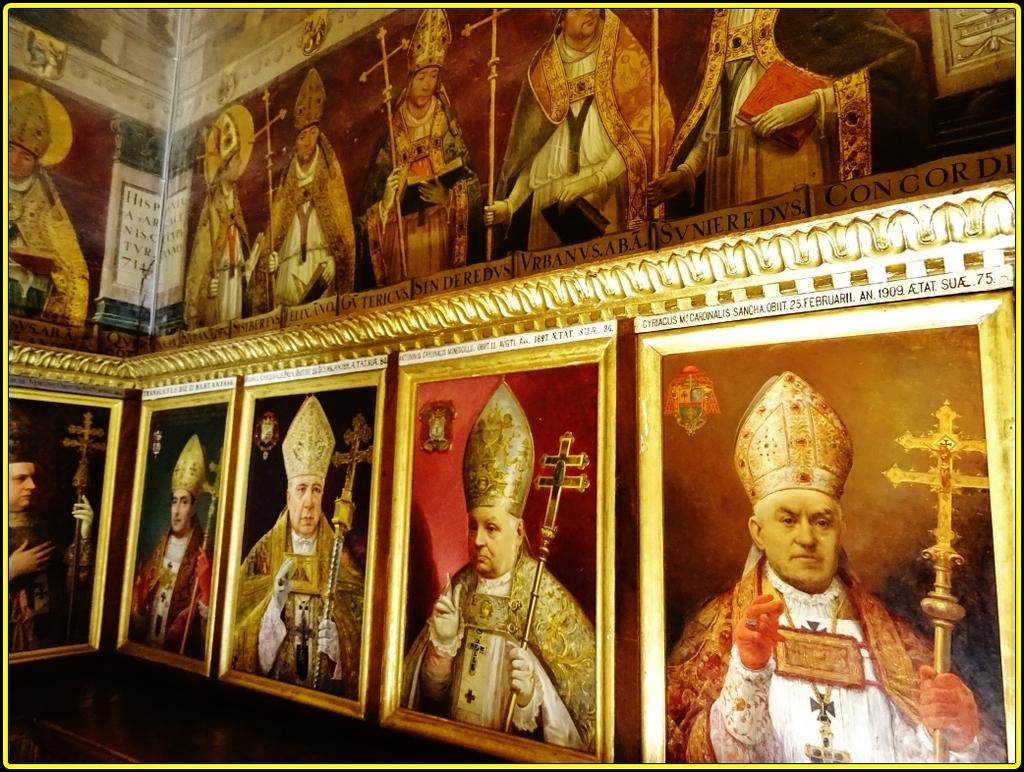What can be seen in the image? There are frames and pictures of persons in the image. Can you describe the frames in the image? The frames are the structures that hold the pictures of persons. What is depicted in the pictures? The pictures contain images of people. What type of carpenter is shown working on the frames in the image? There is no carpenter present in the image, nor is any work being done on the frames. Is there an actor performing in the image? There is no actor or performance depicted in the image; it only contains frames and pictures of persons. 